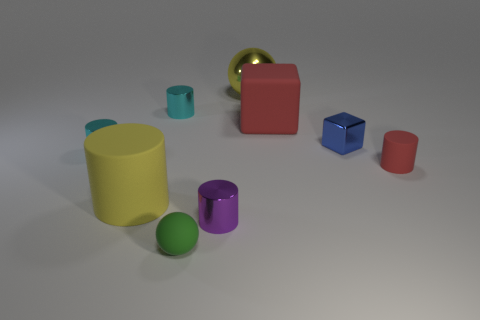Subtract all tiny red rubber cylinders. How many cylinders are left? 4 Subtract all green spheres. How many spheres are left? 1 Subtract all cylinders. How many objects are left? 4 Subtract all blue spheres. How many gray cylinders are left? 0 Add 8 small cyan things. How many small cyan things are left? 10 Add 8 yellow metallic cylinders. How many yellow metallic cylinders exist? 8 Subtract 1 blue blocks. How many objects are left? 8 Subtract 1 blocks. How many blocks are left? 1 Subtract all green cylinders. Subtract all green balls. How many cylinders are left? 5 Subtract all purple things. Subtract all tiny shiny things. How many objects are left? 4 